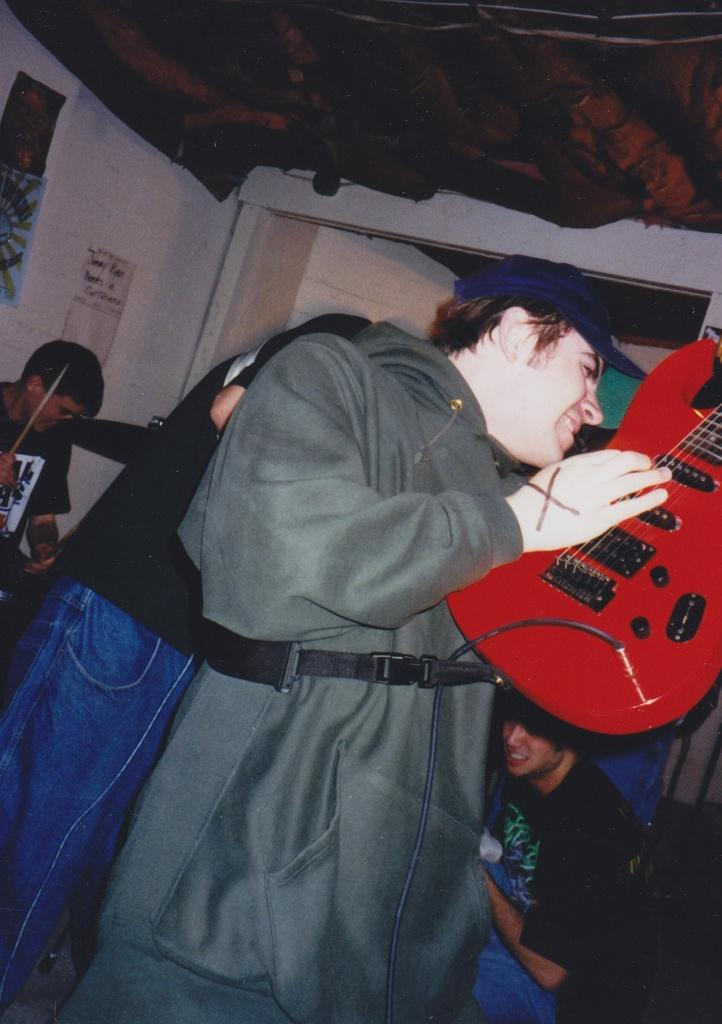What is the person in the image holding? The person is holding a guitar. How is the guitar depicted in the image? The guitar appears to be truncated. Can you describe the background of the image? There are people, a wall, and posters in the background of the image. What type of chain can be seen hanging from the guitar in the image? There is no chain hanging from the guitar in the image. 